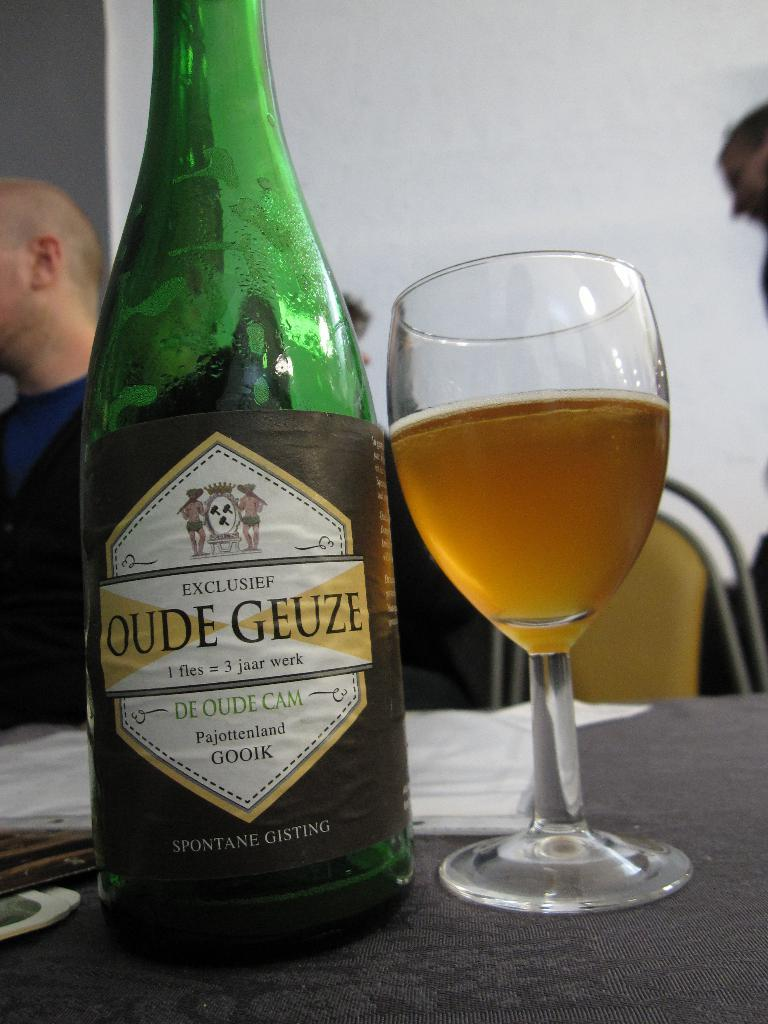<image>
Relay a brief, clear account of the picture shown. "OUDE GEUZE" is printed on the label of a bottle. 